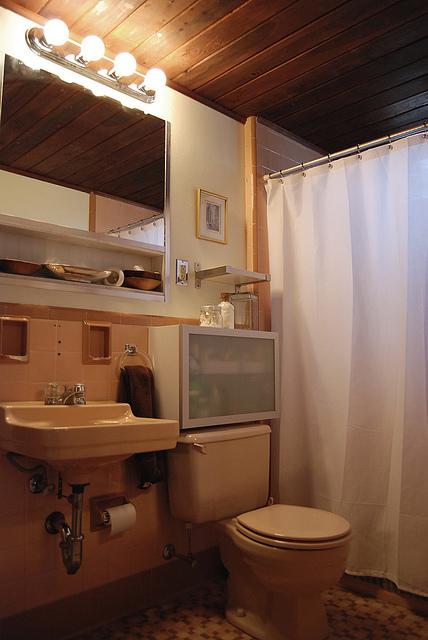How many rolls of toilet paper are visible?
Be succinct. 1. What room of the house is this?
Write a very short answer. Bathroom. How many urinals can be seen?
Quick response, please. 0. Where was this photo taken?
Short answer required. Bathroom. What type of scene is this?
Short answer required. Bathroom. Can you see inside the shower?
Quick response, please. No. What are the towels hanging from?
Be succinct. Ring. Is the toilet clean?
Answer briefly. Yes. 